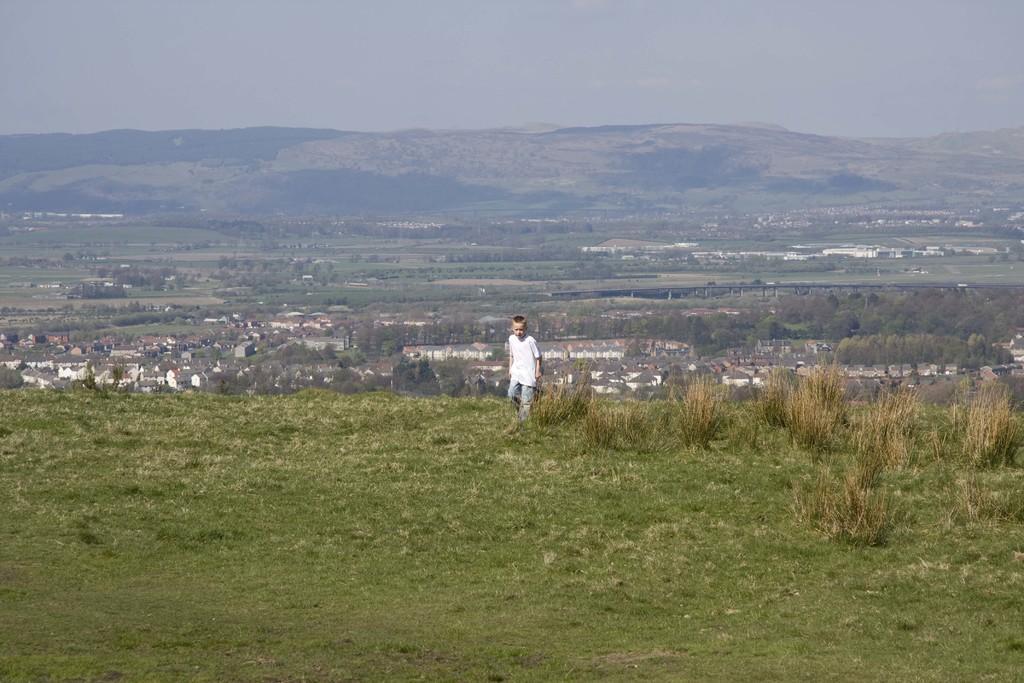Could you give a brief overview of what you see in this image? This is an outside view. At the bottom, I can see the grass on the ground. In the middle of the image there is a boy walking on the ground. On the right side there are some plants. In the background there are many houses, trees and hills. At the top of the image I can see the sky. 